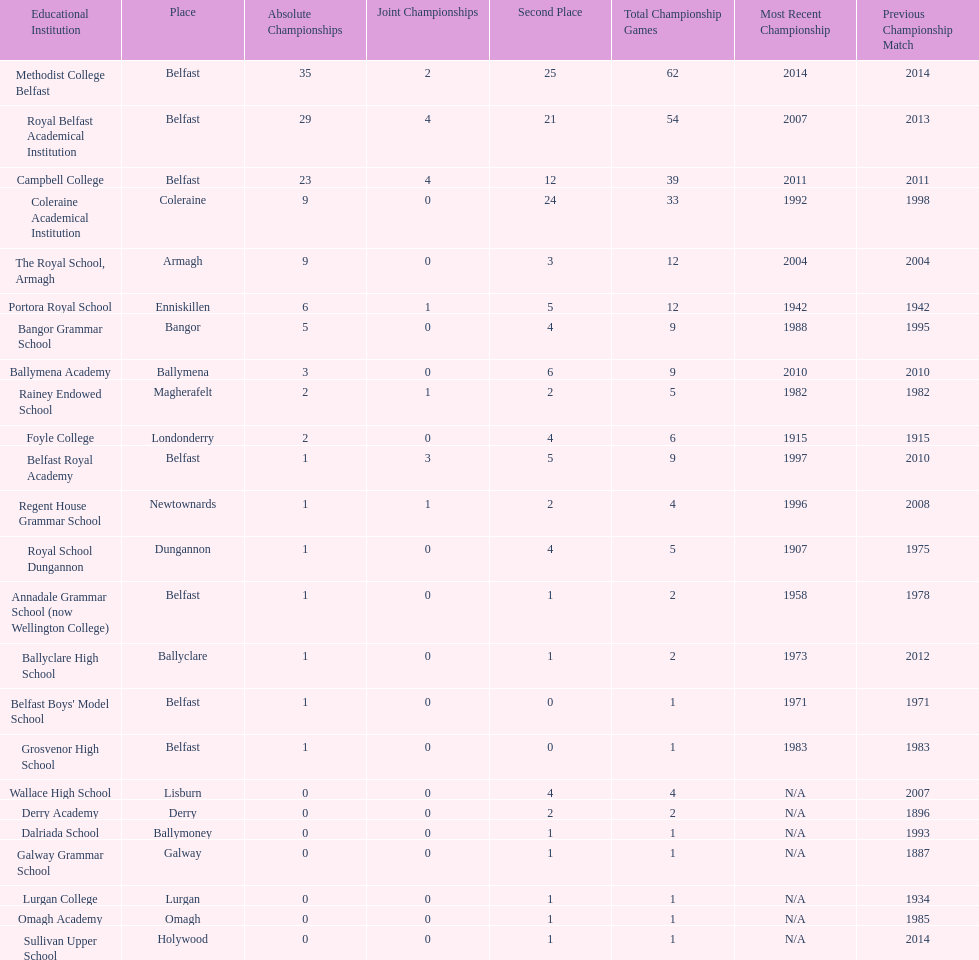What is the difference in runners-up from coleraine academical institution and royal school dungannon? 20. 